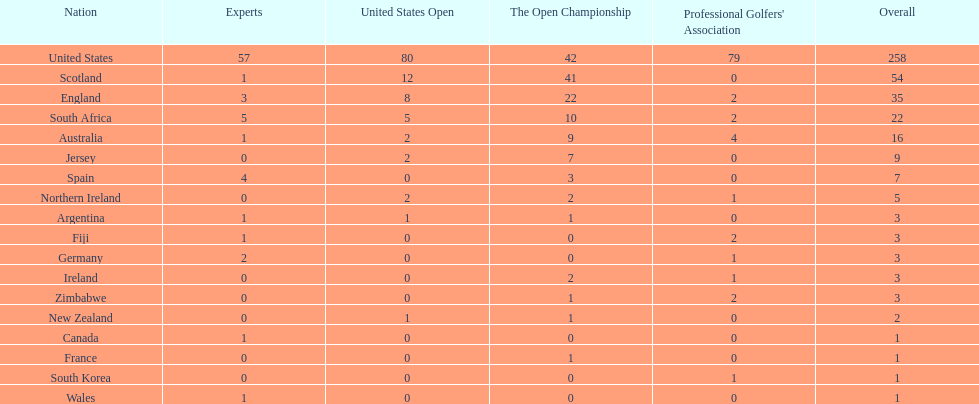What are the number of pga winning golfers that zimbabwe has? 2. 